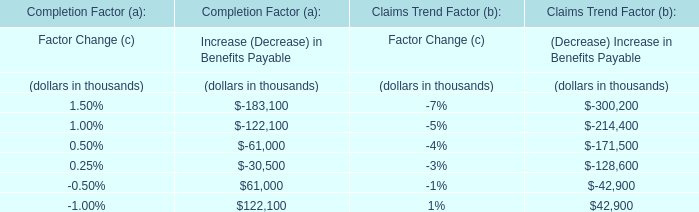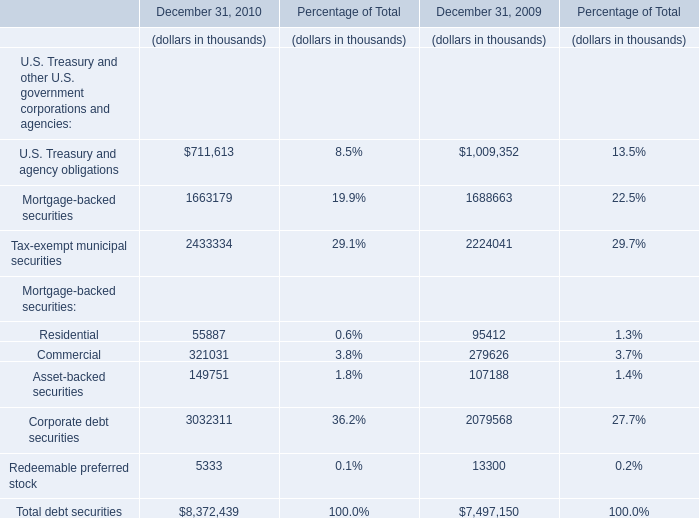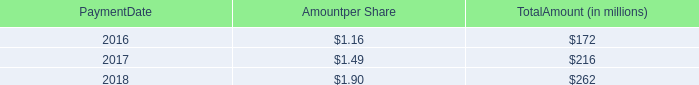What is the average value of the Asset-backed securities at December 31, 2009 and the Asset-backed securities at December 31, 2010 ? (in thousand) 
Computations: ((107188 + 149751) / 2)
Answer: 128469.5. 